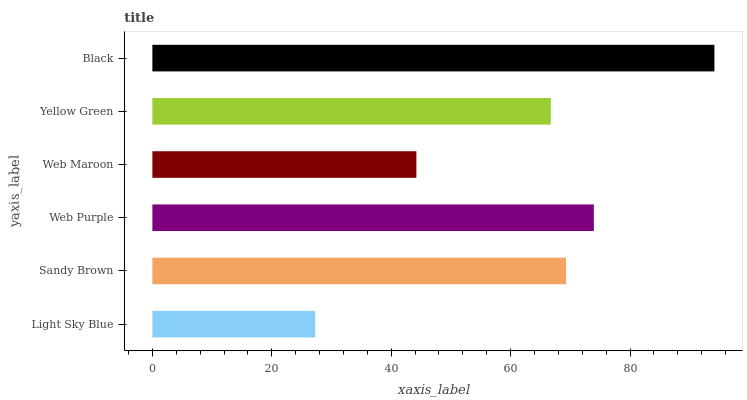Is Light Sky Blue the minimum?
Answer yes or no. Yes. Is Black the maximum?
Answer yes or no. Yes. Is Sandy Brown the minimum?
Answer yes or no. No. Is Sandy Brown the maximum?
Answer yes or no. No. Is Sandy Brown greater than Light Sky Blue?
Answer yes or no. Yes. Is Light Sky Blue less than Sandy Brown?
Answer yes or no. Yes. Is Light Sky Blue greater than Sandy Brown?
Answer yes or no. No. Is Sandy Brown less than Light Sky Blue?
Answer yes or no. No. Is Sandy Brown the high median?
Answer yes or no. Yes. Is Yellow Green the low median?
Answer yes or no. Yes. Is Web Purple the high median?
Answer yes or no. No. Is Light Sky Blue the low median?
Answer yes or no. No. 